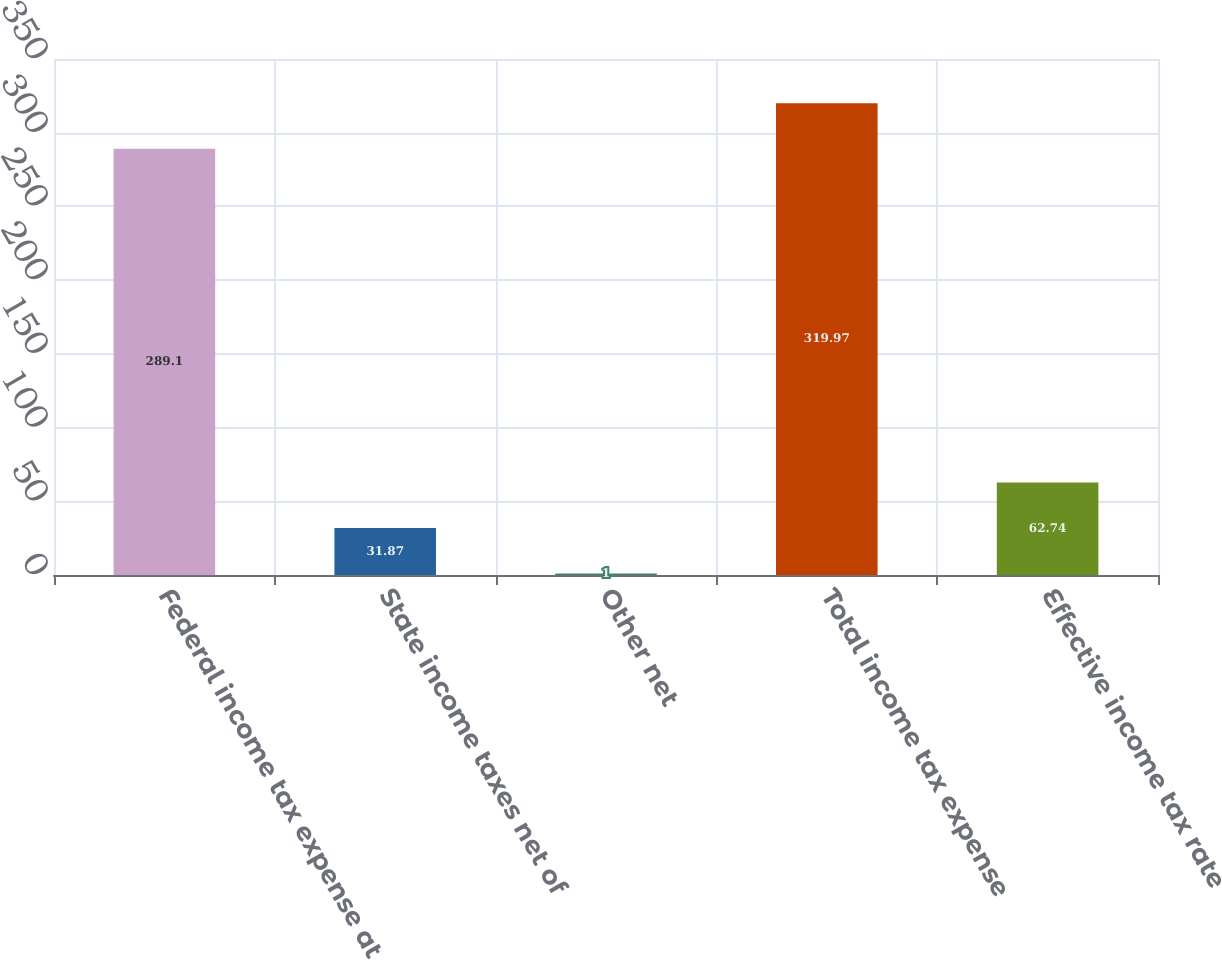<chart> <loc_0><loc_0><loc_500><loc_500><bar_chart><fcel>Federal income tax expense at<fcel>State income taxes net of<fcel>Other net<fcel>Total income tax expense<fcel>Effective income tax rate<nl><fcel>289.1<fcel>31.87<fcel>1<fcel>319.97<fcel>62.74<nl></chart> 